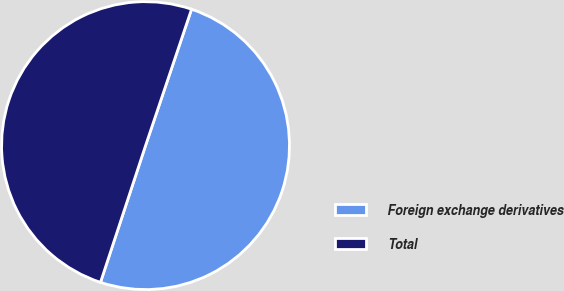Convert chart. <chart><loc_0><loc_0><loc_500><loc_500><pie_chart><fcel>Foreign exchange derivatives<fcel>Total<nl><fcel>49.89%<fcel>50.11%<nl></chart> 